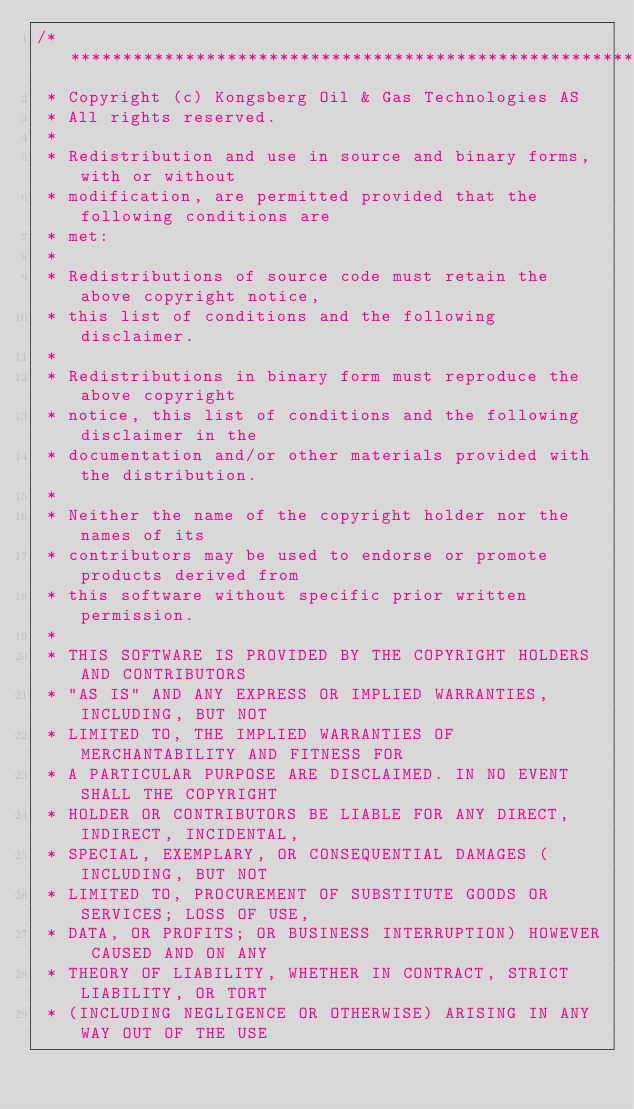<code> <loc_0><loc_0><loc_500><loc_500><_ObjectiveC_>/**************************************************************************\
 * Copyright (c) Kongsberg Oil & Gas Technologies AS
 * All rights reserved.
 * 
 * Redistribution and use in source and binary forms, with or without
 * modification, are permitted provided that the following conditions are
 * met:
 * 
 * Redistributions of source code must retain the above copyright notice,
 * this list of conditions and the following disclaimer.
 * 
 * Redistributions in binary form must reproduce the above copyright
 * notice, this list of conditions and the following disclaimer in the
 * documentation and/or other materials provided with the distribution.
 * 
 * Neither the name of the copyright holder nor the names of its
 * contributors may be used to endorse or promote products derived from
 * this software without specific prior written permission.
 * 
 * THIS SOFTWARE IS PROVIDED BY THE COPYRIGHT HOLDERS AND CONTRIBUTORS
 * "AS IS" AND ANY EXPRESS OR IMPLIED WARRANTIES, INCLUDING, BUT NOT
 * LIMITED TO, THE IMPLIED WARRANTIES OF MERCHANTABILITY AND FITNESS FOR
 * A PARTICULAR PURPOSE ARE DISCLAIMED. IN NO EVENT SHALL THE COPYRIGHT
 * HOLDER OR CONTRIBUTORS BE LIABLE FOR ANY DIRECT, INDIRECT, INCIDENTAL,
 * SPECIAL, EXEMPLARY, OR CONSEQUENTIAL DAMAGES (INCLUDING, BUT NOT
 * LIMITED TO, PROCUREMENT OF SUBSTITUTE GOODS OR SERVICES; LOSS OF USE,
 * DATA, OR PROFITS; OR BUSINESS INTERRUPTION) HOWEVER CAUSED AND ON ANY
 * THEORY OF LIABILITY, WHETHER IN CONTRACT, STRICT LIABILITY, OR TORT
 * (INCLUDING NEGLIGENCE OR OTHERWISE) ARISING IN ANY WAY OUT OF THE USE</code> 